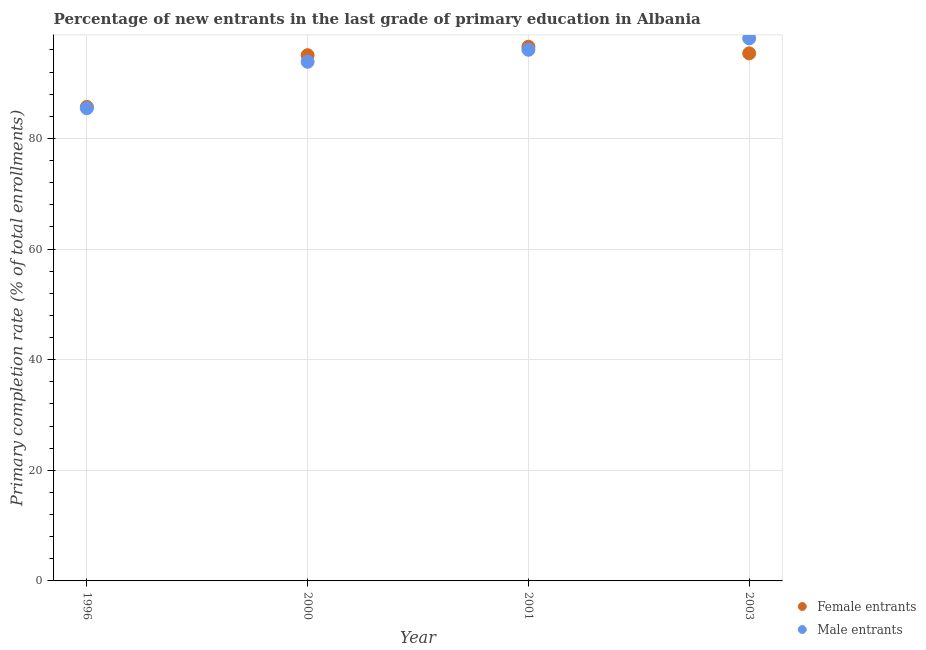How many different coloured dotlines are there?
Ensure brevity in your answer.  2. What is the primary completion rate of male entrants in 2000?
Ensure brevity in your answer.  93.85. Across all years, what is the maximum primary completion rate of male entrants?
Provide a succinct answer. 98.08. Across all years, what is the minimum primary completion rate of male entrants?
Offer a very short reply. 85.45. What is the total primary completion rate of male entrants in the graph?
Your answer should be very brief. 373.4. What is the difference between the primary completion rate of male entrants in 2001 and that in 2003?
Provide a succinct answer. -2.06. What is the difference between the primary completion rate of female entrants in 2003 and the primary completion rate of male entrants in 1996?
Make the answer very short. 9.91. What is the average primary completion rate of male entrants per year?
Provide a succinct answer. 93.35. In the year 1996, what is the difference between the primary completion rate of male entrants and primary completion rate of female entrants?
Your answer should be very brief. -0.24. What is the ratio of the primary completion rate of female entrants in 1996 to that in 2000?
Offer a very short reply. 0.9. Is the difference between the primary completion rate of male entrants in 1996 and 2000 greater than the difference between the primary completion rate of female entrants in 1996 and 2000?
Ensure brevity in your answer.  Yes. What is the difference between the highest and the second highest primary completion rate of male entrants?
Your answer should be compact. 2.06. What is the difference between the highest and the lowest primary completion rate of male entrants?
Your response must be concise. 12.63. Is the sum of the primary completion rate of female entrants in 1996 and 2000 greater than the maximum primary completion rate of male entrants across all years?
Offer a terse response. Yes. How many dotlines are there?
Provide a succinct answer. 2. How many legend labels are there?
Provide a short and direct response. 2. How are the legend labels stacked?
Provide a succinct answer. Vertical. What is the title of the graph?
Provide a short and direct response. Percentage of new entrants in the last grade of primary education in Albania. What is the label or title of the X-axis?
Provide a succinct answer. Year. What is the label or title of the Y-axis?
Offer a terse response. Primary completion rate (% of total enrollments). What is the Primary completion rate (% of total enrollments) in Female entrants in 1996?
Offer a terse response. 85.69. What is the Primary completion rate (% of total enrollments) in Male entrants in 1996?
Ensure brevity in your answer.  85.45. What is the Primary completion rate (% of total enrollments) of Female entrants in 2000?
Provide a short and direct response. 95.04. What is the Primary completion rate (% of total enrollments) of Male entrants in 2000?
Your answer should be compact. 93.85. What is the Primary completion rate (% of total enrollments) of Female entrants in 2001?
Your answer should be compact. 96.57. What is the Primary completion rate (% of total enrollments) of Male entrants in 2001?
Offer a very short reply. 96.02. What is the Primary completion rate (% of total enrollments) of Female entrants in 2003?
Give a very brief answer. 95.37. What is the Primary completion rate (% of total enrollments) in Male entrants in 2003?
Your answer should be compact. 98.08. Across all years, what is the maximum Primary completion rate (% of total enrollments) in Female entrants?
Keep it short and to the point. 96.57. Across all years, what is the maximum Primary completion rate (% of total enrollments) in Male entrants?
Your answer should be very brief. 98.08. Across all years, what is the minimum Primary completion rate (% of total enrollments) in Female entrants?
Your response must be concise. 85.69. Across all years, what is the minimum Primary completion rate (% of total enrollments) of Male entrants?
Make the answer very short. 85.45. What is the total Primary completion rate (% of total enrollments) in Female entrants in the graph?
Your answer should be compact. 372.67. What is the total Primary completion rate (% of total enrollments) in Male entrants in the graph?
Offer a very short reply. 373.4. What is the difference between the Primary completion rate (% of total enrollments) in Female entrants in 1996 and that in 2000?
Your answer should be compact. -9.34. What is the difference between the Primary completion rate (% of total enrollments) in Male entrants in 1996 and that in 2000?
Provide a succinct answer. -8.39. What is the difference between the Primary completion rate (% of total enrollments) in Female entrants in 1996 and that in 2001?
Provide a succinct answer. -10.87. What is the difference between the Primary completion rate (% of total enrollments) of Male entrants in 1996 and that in 2001?
Provide a succinct answer. -10.56. What is the difference between the Primary completion rate (% of total enrollments) in Female entrants in 1996 and that in 2003?
Your response must be concise. -9.67. What is the difference between the Primary completion rate (% of total enrollments) of Male entrants in 1996 and that in 2003?
Your answer should be compact. -12.63. What is the difference between the Primary completion rate (% of total enrollments) in Female entrants in 2000 and that in 2001?
Give a very brief answer. -1.53. What is the difference between the Primary completion rate (% of total enrollments) in Male entrants in 2000 and that in 2001?
Provide a succinct answer. -2.17. What is the difference between the Primary completion rate (% of total enrollments) of Female entrants in 2000 and that in 2003?
Provide a succinct answer. -0.33. What is the difference between the Primary completion rate (% of total enrollments) of Male entrants in 2000 and that in 2003?
Make the answer very short. -4.23. What is the difference between the Primary completion rate (% of total enrollments) in Female entrants in 2001 and that in 2003?
Provide a succinct answer. 1.2. What is the difference between the Primary completion rate (% of total enrollments) in Male entrants in 2001 and that in 2003?
Provide a short and direct response. -2.06. What is the difference between the Primary completion rate (% of total enrollments) of Female entrants in 1996 and the Primary completion rate (% of total enrollments) of Male entrants in 2000?
Offer a very short reply. -8.15. What is the difference between the Primary completion rate (% of total enrollments) of Female entrants in 1996 and the Primary completion rate (% of total enrollments) of Male entrants in 2001?
Provide a succinct answer. -10.32. What is the difference between the Primary completion rate (% of total enrollments) in Female entrants in 1996 and the Primary completion rate (% of total enrollments) in Male entrants in 2003?
Keep it short and to the point. -12.39. What is the difference between the Primary completion rate (% of total enrollments) of Female entrants in 2000 and the Primary completion rate (% of total enrollments) of Male entrants in 2001?
Offer a very short reply. -0.98. What is the difference between the Primary completion rate (% of total enrollments) of Female entrants in 2000 and the Primary completion rate (% of total enrollments) of Male entrants in 2003?
Offer a terse response. -3.04. What is the difference between the Primary completion rate (% of total enrollments) of Female entrants in 2001 and the Primary completion rate (% of total enrollments) of Male entrants in 2003?
Your response must be concise. -1.51. What is the average Primary completion rate (% of total enrollments) in Female entrants per year?
Give a very brief answer. 93.17. What is the average Primary completion rate (% of total enrollments) of Male entrants per year?
Your answer should be compact. 93.35. In the year 1996, what is the difference between the Primary completion rate (% of total enrollments) in Female entrants and Primary completion rate (% of total enrollments) in Male entrants?
Provide a short and direct response. 0.24. In the year 2000, what is the difference between the Primary completion rate (% of total enrollments) of Female entrants and Primary completion rate (% of total enrollments) of Male entrants?
Make the answer very short. 1.19. In the year 2001, what is the difference between the Primary completion rate (% of total enrollments) in Female entrants and Primary completion rate (% of total enrollments) in Male entrants?
Offer a terse response. 0.55. In the year 2003, what is the difference between the Primary completion rate (% of total enrollments) in Female entrants and Primary completion rate (% of total enrollments) in Male entrants?
Your answer should be very brief. -2.71. What is the ratio of the Primary completion rate (% of total enrollments) of Female entrants in 1996 to that in 2000?
Offer a very short reply. 0.9. What is the ratio of the Primary completion rate (% of total enrollments) in Male entrants in 1996 to that in 2000?
Offer a terse response. 0.91. What is the ratio of the Primary completion rate (% of total enrollments) in Female entrants in 1996 to that in 2001?
Your answer should be very brief. 0.89. What is the ratio of the Primary completion rate (% of total enrollments) of Male entrants in 1996 to that in 2001?
Your answer should be compact. 0.89. What is the ratio of the Primary completion rate (% of total enrollments) in Female entrants in 1996 to that in 2003?
Offer a terse response. 0.9. What is the ratio of the Primary completion rate (% of total enrollments) of Male entrants in 1996 to that in 2003?
Offer a terse response. 0.87. What is the ratio of the Primary completion rate (% of total enrollments) in Female entrants in 2000 to that in 2001?
Your answer should be compact. 0.98. What is the ratio of the Primary completion rate (% of total enrollments) in Male entrants in 2000 to that in 2001?
Offer a very short reply. 0.98. What is the ratio of the Primary completion rate (% of total enrollments) in Female entrants in 2000 to that in 2003?
Your response must be concise. 1. What is the ratio of the Primary completion rate (% of total enrollments) of Male entrants in 2000 to that in 2003?
Provide a short and direct response. 0.96. What is the ratio of the Primary completion rate (% of total enrollments) of Female entrants in 2001 to that in 2003?
Offer a very short reply. 1.01. What is the ratio of the Primary completion rate (% of total enrollments) in Male entrants in 2001 to that in 2003?
Your answer should be compact. 0.98. What is the difference between the highest and the second highest Primary completion rate (% of total enrollments) of Female entrants?
Provide a succinct answer. 1.2. What is the difference between the highest and the second highest Primary completion rate (% of total enrollments) in Male entrants?
Provide a succinct answer. 2.06. What is the difference between the highest and the lowest Primary completion rate (% of total enrollments) of Female entrants?
Ensure brevity in your answer.  10.87. What is the difference between the highest and the lowest Primary completion rate (% of total enrollments) of Male entrants?
Ensure brevity in your answer.  12.63. 